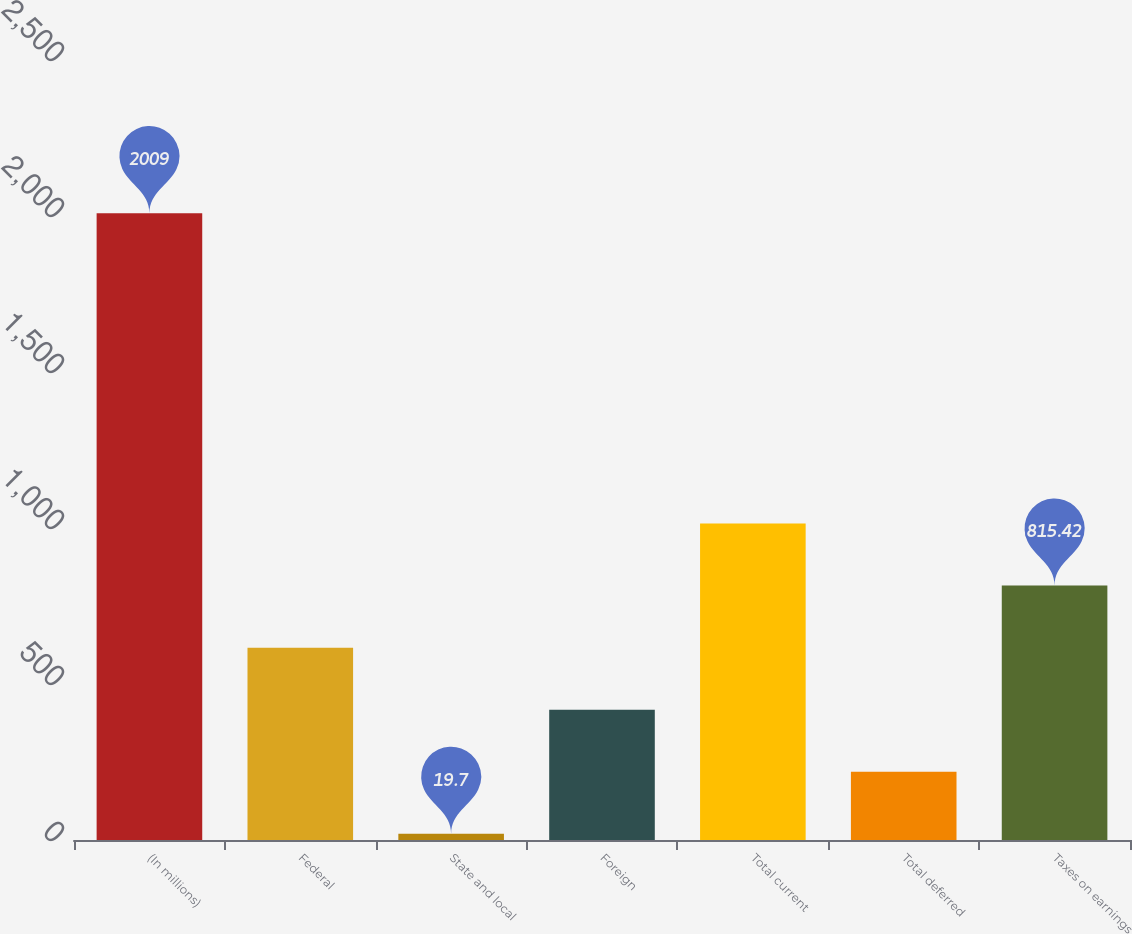Convert chart. <chart><loc_0><loc_0><loc_500><loc_500><bar_chart><fcel>(In millions)<fcel>Federal<fcel>State and local<fcel>Foreign<fcel>Total current<fcel>Total deferred<fcel>Taxes on earnings<nl><fcel>2009<fcel>616.49<fcel>19.7<fcel>417.56<fcel>1014.35<fcel>218.63<fcel>815.42<nl></chart> 